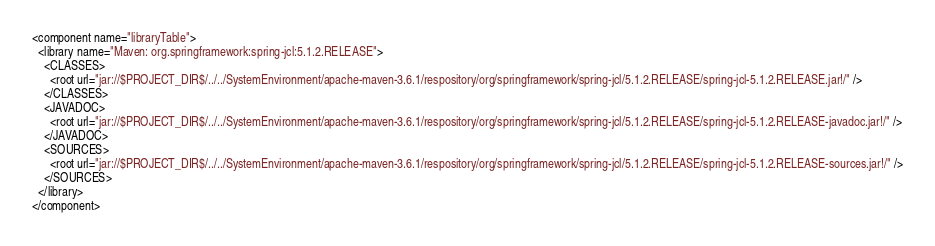Convert code to text. <code><loc_0><loc_0><loc_500><loc_500><_XML_><component name="libraryTable">
  <library name="Maven: org.springframework:spring-jcl:5.1.2.RELEASE">
    <CLASSES>
      <root url="jar://$PROJECT_DIR$/../../SystemEnvironment/apache-maven-3.6.1/respository/org/springframework/spring-jcl/5.1.2.RELEASE/spring-jcl-5.1.2.RELEASE.jar!/" />
    </CLASSES>
    <JAVADOC>
      <root url="jar://$PROJECT_DIR$/../../SystemEnvironment/apache-maven-3.6.1/respository/org/springframework/spring-jcl/5.1.2.RELEASE/spring-jcl-5.1.2.RELEASE-javadoc.jar!/" />
    </JAVADOC>
    <SOURCES>
      <root url="jar://$PROJECT_DIR$/../../SystemEnvironment/apache-maven-3.6.1/respository/org/springframework/spring-jcl/5.1.2.RELEASE/spring-jcl-5.1.2.RELEASE-sources.jar!/" />
    </SOURCES>
  </library>
</component></code> 